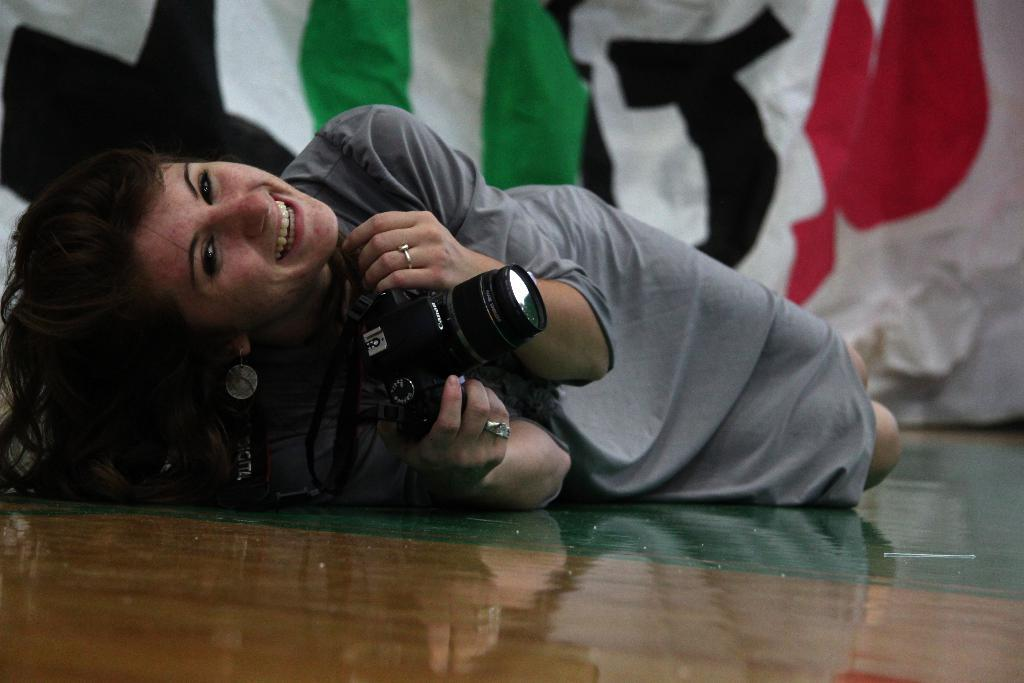What is the person in the image doing? The person is lying on the floor in the image. What is the person holding while lying on the floor? The person is holding a camera. What can be seen in the background of the image? There is a banner at the back of the scene. What type of writing can be seen on the cracker in the image? There is no cracker present in the image, and therefore no writing on a cracker can be observed. 